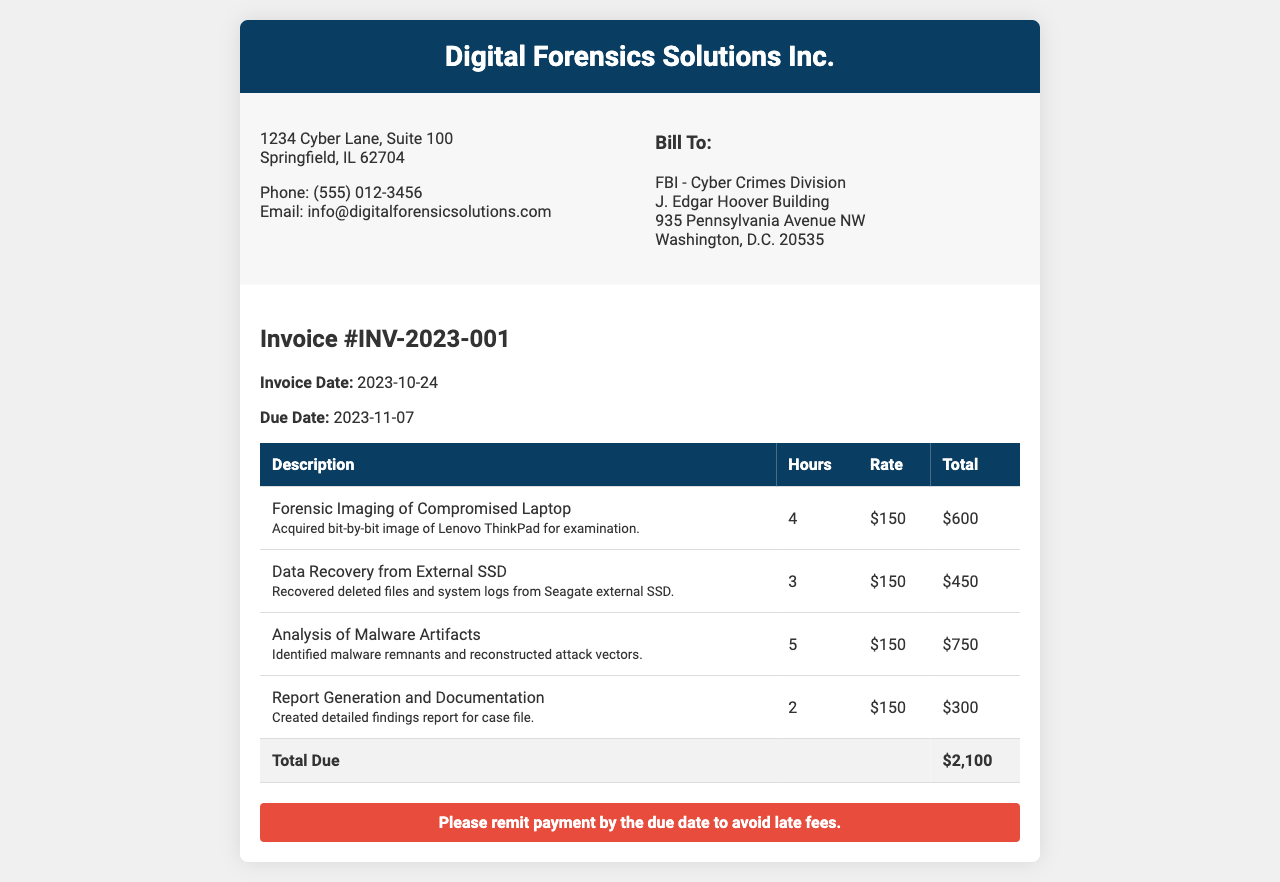what is the invoice number? The invoice number is listed at the top of the invoice and is formatted as INV-YYYY-XXX.
Answer: INV-2023-001 what is the total due amount? The total due is summed from all individual tasks listed in the invoice.
Answer: $2,100 what is the invoice date? The invoice date is specifically mentioned in the document under invoice details.
Answer: 2023-10-24 how many hours were spent on Analysis of Malware Artifacts? The number of hours is provided in the table under the corresponding task.
Answer: 5 what is the hourly rate for services rendered? The hourly rate is consistent across all tasks and is indicated in the table.
Answer: $150 who is the client in this invoice? The client is specified in the billing section of the invoice.
Answer: FBI - Cyber Crimes Division when is the payment due date? The due date for payment is specified in the invoice details.
Answer: 2023-11-07 how many tasks are listed in the invoice? The invoice lists the number of distinct services performed.
Answer: 4 what is the description for the first task? The description for each task is detailed in the invoice table.
Answer: Forensic Imaging of Compromised Laptop 